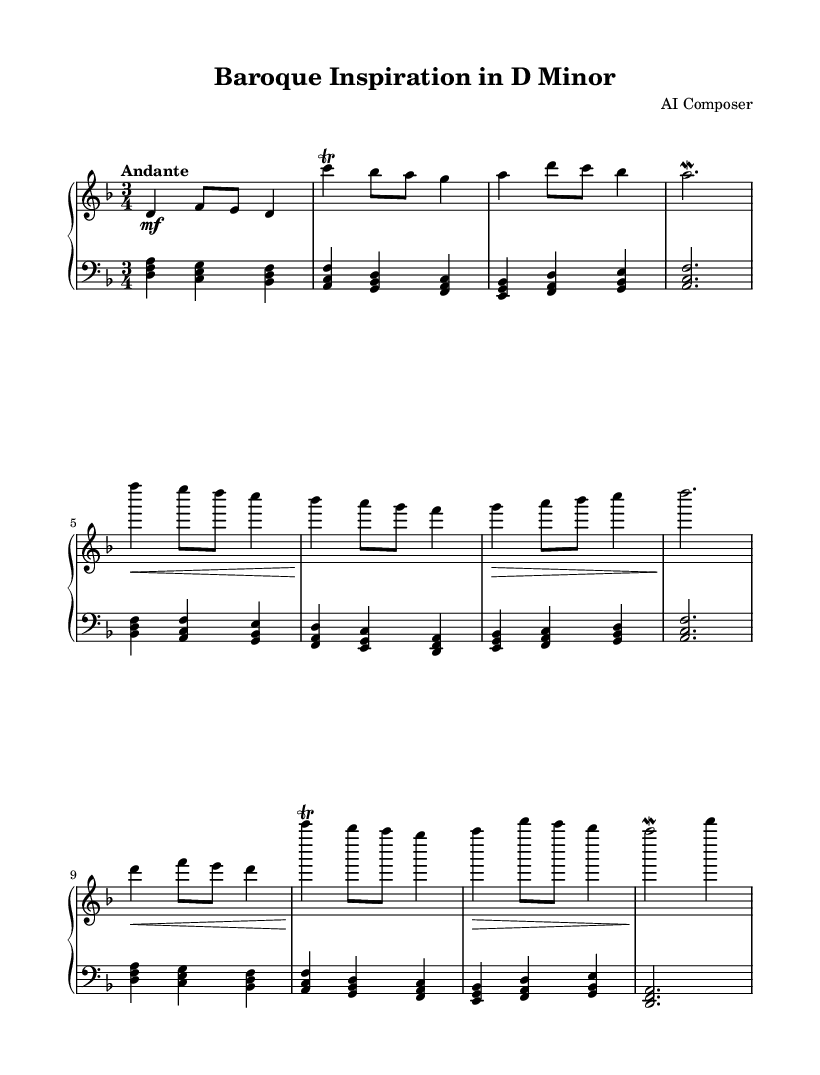What is the key signature of this music? The key signature in the music indicates two flats, which corresponds to D minor.
Answer: D minor What is the time signature of this composition? The time signature shown in the sheet music is 3/4, meaning there are three beats per measure and the quarter note gets one beat.
Answer: 3/4 What is the tempo marking for this piece? The tempo marking found above the staff indicates that the piece should be played at a moderate pace, specifically "Andante."
Answer: Andante How many sections are in the composition? The composition features three sections labeled as A, B, and A', with the A' section being a variation of the A section.
Answer: 3 What ornament appears frequently in the upper staff? The upper staff includes a trill ornament, which is indicated by the command 'trill' placed before specific notes.
Answer: Trill Which musical device is used between the last note of the A' section and the beginning of the piece? The last measure of the A' section features a mordent, which is an ornament indicating to quickly alternate between the written note and the note above it.
Answer: Mordent What type of harmony is primarily used in the lower staff? The lower staff predominantly utilizes triadic harmonies, which are groups of three notes played together, typically forming chords.
Answer: Triadic 